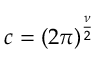<formula> <loc_0><loc_0><loc_500><loc_500>c = { \left ( 2 \pi \right ) } ^ { \frac { \nu } { 2 } }</formula> 